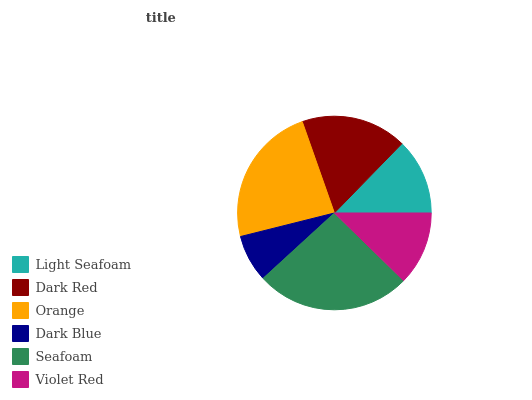Is Dark Blue the minimum?
Answer yes or no. Yes. Is Seafoam the maximum?
Answer yes or no. Yes. Is Dark Red the minimum?
Answer yes or no. No. Is Dark Red the maximum?
Answer yes or no. No. Is Dark Red greater than Light Seafoam?
Answer yes or no. Yes. Is Light Seafoam less than Dark Red?
Answer yes or no. Yes. Is Light Seafoam greater than Dark Red?
Answer yes or no. No. Is Dark Red less than Light Seafoam?
Answer yes or no. No. Is Dark Red the high median?
Answer yes or no. Yes. Is Light Seafoam the low median?
Answer yes or no. Yes. Is Orange the high median?
Answer yes or no. No. Is Dark Red the low median?
Answer yes or no. No. 